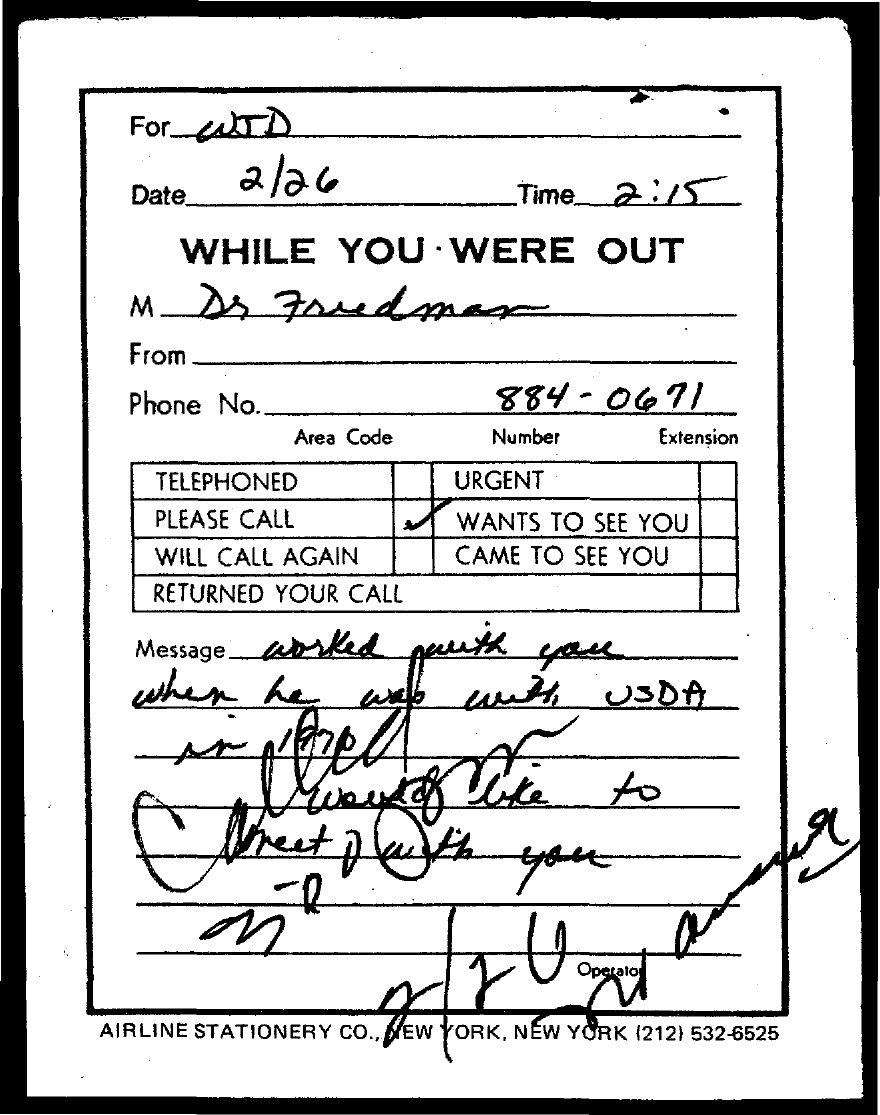Draw attention to some important aspects in this diagram. The date mentioned in the document is February 26. The time mentioned in the document is 2:15. 